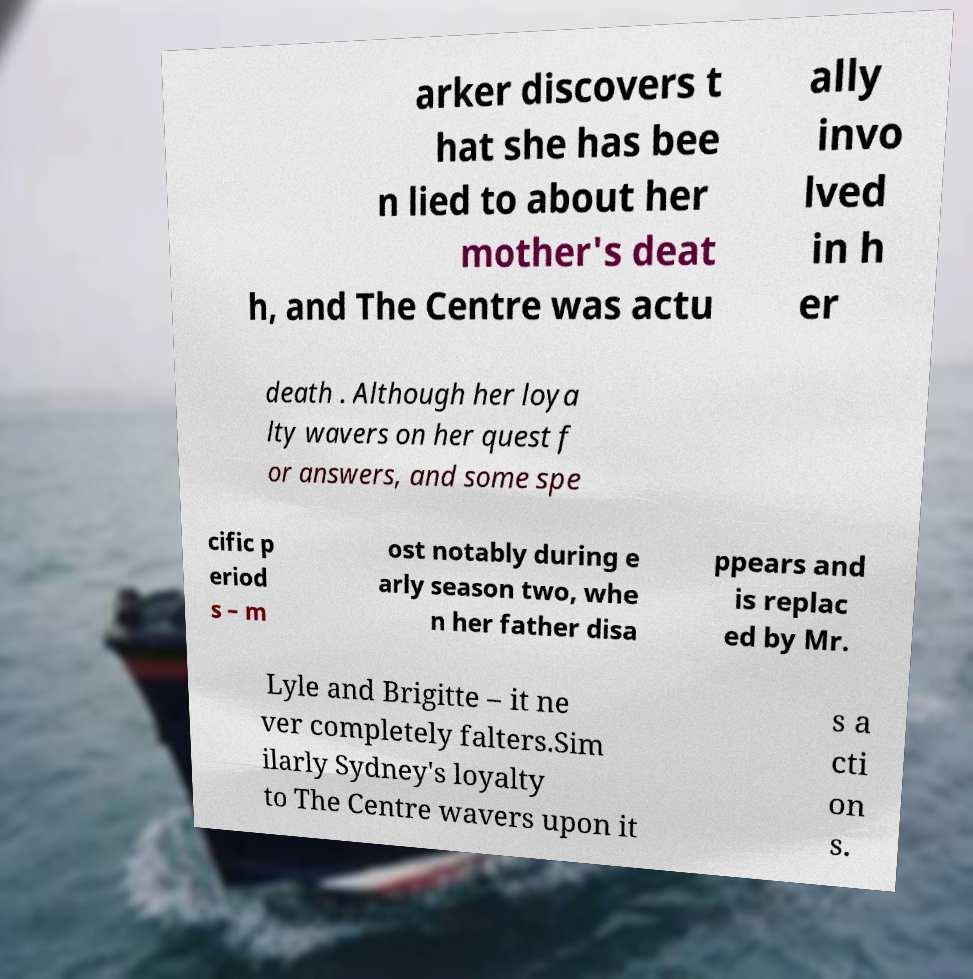For documentation purposes, I need the text within this image transcribed. Could you provide that? arker discovers t hat she has bee n lied to about her mother's deat h, and The Centre was actu ally invo lved in h er death . Although her loya lty wavers on her quest f or answers, and some spe cific p eriod s – m ost notably during e arly season two, whe n her father disa ppears and is replac ed by Mr. Lyle and Brigitte – it ne ver completely falters.Sim ilarly Sydney's loyalty to The Centre wavers upon it s a cti on s. 